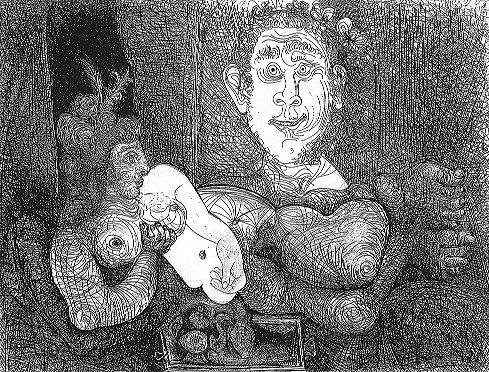Can you describe the emotions conveyed by the central figure in this artwork? The central figure, with a notably large head, displays an expression that is both whimsical and contemplative. The eyes, wide and attentive, along with a slight smile, suggest a sense of wonder and perhaps a hint of bemusement. This expression plays into the overall surreal and dream-like quality of the image, inviting viewers to ponder deeper meanings or narratives. 